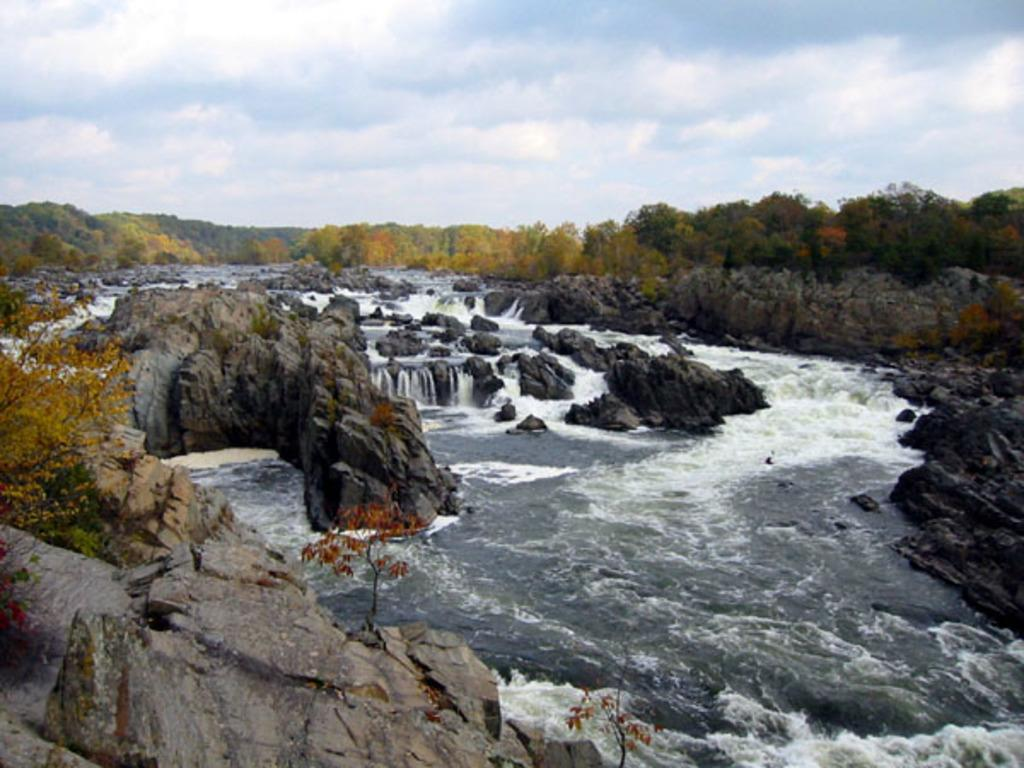What type of natural elements can be seen in the image? There are rocks, water, trees, and the sky visible in the image. Can you describe the water in the image? The water is visible in the image, but its specific characteristics are not mentioned. What is visible in the background of the image? The sky is visible in the background of the image, and there are clouds in the sky. What type of lumber is being used to build the bridge in the image? There is no bridge present in the image, so it is not possible to determine the type of lumber being used. 